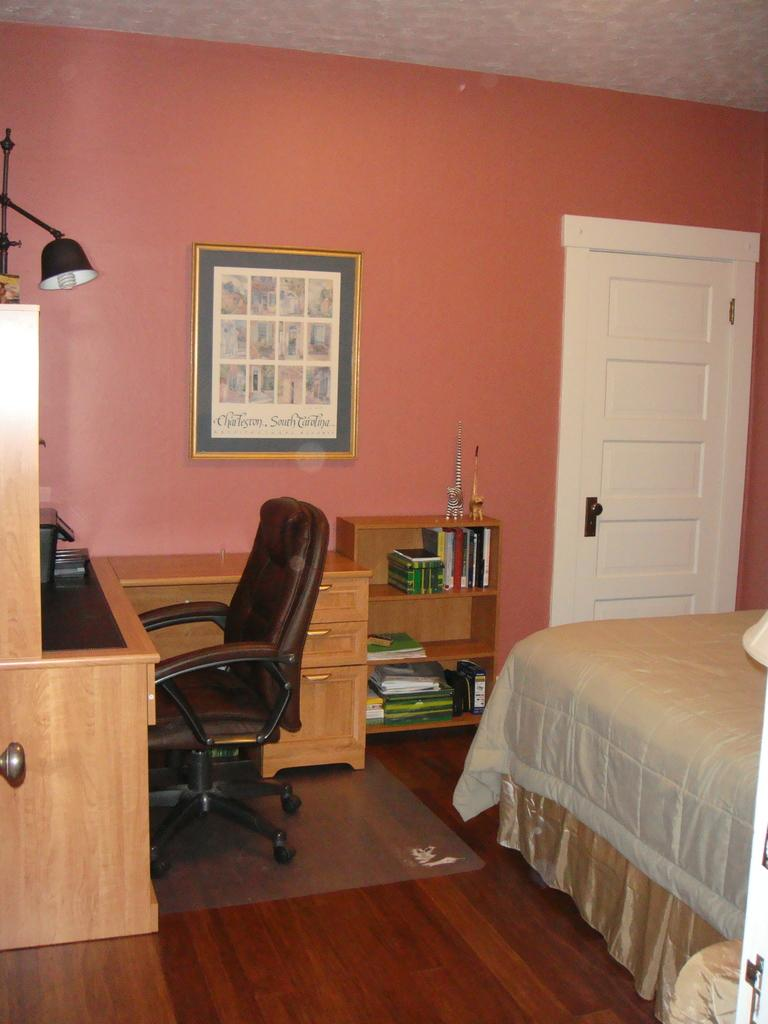What type of furniture is present in the image? There is a chair and a bed in the image. What part of the room is visible in the image? The floor is visible in the image. What is used for storage in the image? There is a shelf and cupboards in the image for storage. What is hanging on the wall in the image? There is a frame on the wall in the image. What is the source of light in the image? There is a lamp in the image. What is the purpose of the door in the image? The door in the image is used for entering or exiting the room. Can you see any bomb in the image? No, there is no bomb present in the image. Is there a lake visible in the image? No, there is no lake present in the image. 